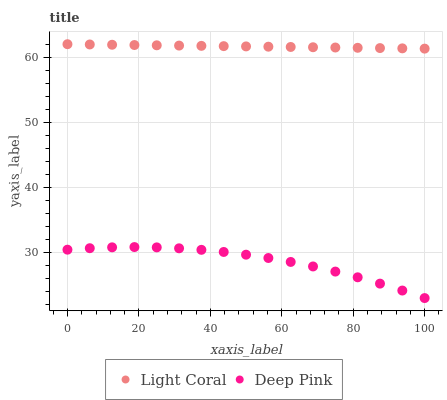Does Deep Pink have the minimum area under the curve?
Answer yes or no. Yes. Does Light Coral have the maximum area under the curve?
Answer yes or no. Yes. Does Deep Pink have the maximum area under the curve?
Answer yes or no. No. Is Light Coral the smoothest?
Answer yes or no. Yes. Is Deep Pink the roughest?
Answer yes or no. Yes. Is Deep Pink the smoothest?
Answer yes or no. No. Does Deep Pink have the lowest value?
Answer yes or no. Yes. Does Light Coral have the highest value?
Answer yes or no. Yes. Does Deep Pink have the highest value?
Answer yes or no. No. Is Deep Pink less than Light Coral?
Answer yes or no. Yes. Is Light Coral greater than Deep Pink?
Answer yes or no. Yes. Does Deep Pink intersect Light Coral?
Answer yes or no. No. 